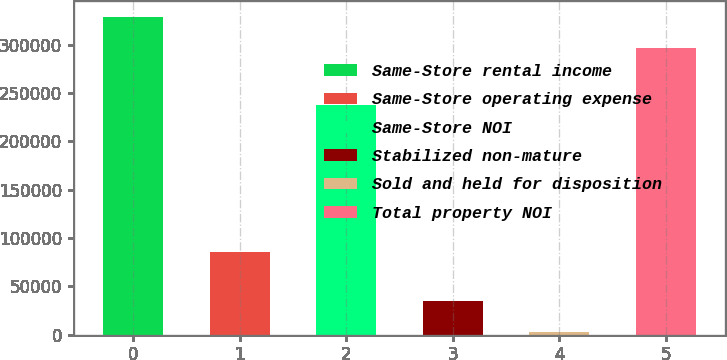Convert chart. <chart><loc_0><loc_0><loc_500><loc_500><bar_chart><fcel>Same-Store rental income<fcel>Same-Store operating expense<fcel>Same-Store NOI<fcel>Stabilized non-mature<fcel>Sold and held for disposition<fcel>Total property NOI<nl><fcel>329158<fcel>85436<fcel>237532<fcel>34635.9<fcel>2599<fcel>297121<nl></chart> 